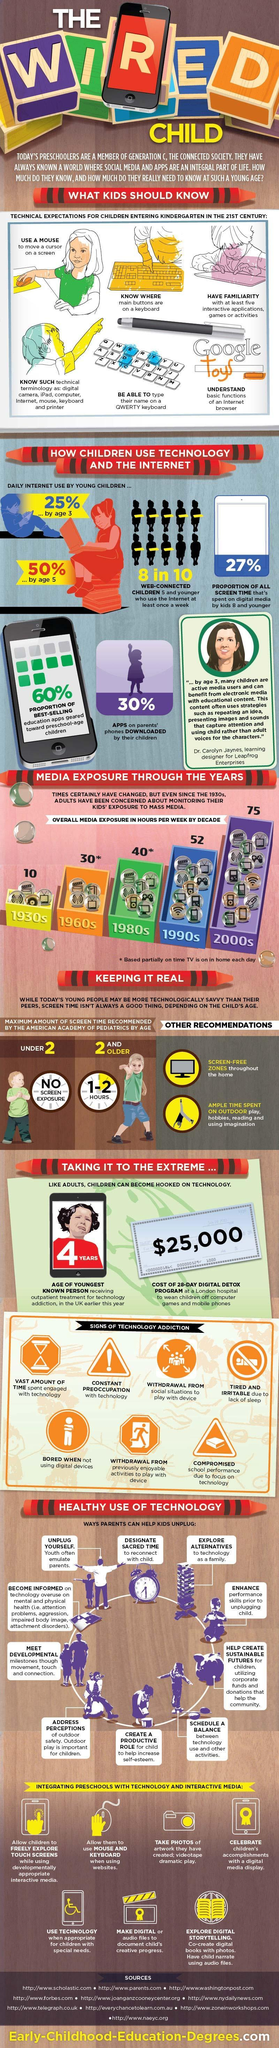What is the cost of a 28 day digital detox program in London?
Answer the question with a short phrase. $25,000 What should be enhanced prior to unplugging a child from technology? Performance skills What is the second 'sign of technology addiction' mentioned here? Constant preoccupation with technology What is the age of the youngest person receiving treatment for technology addiction? 4 years How many hours per week were children exposed to media in the 1930s? 10 Besides restricting screen time, what are the two 'other recommendations' to reduce screen time? Screen-free zones, ample time spent on outdoor What is the maximum amount of screen time recommended by pediatricians for children under 2? New screen exposure According to pediatricians, how many hours of screen time should a child of age 2 be allowed to have? 1 - 2 hours How many signs of technology addictions are shown here? 7 Who do youth often emulate? Parents What percent of the educational apps are aimed towards preschool students? 60% How many more hours/week exposure do the 1990's children have when compared to to the 1980s? 12 Which decade shows the second highest media exposure in children? 1990s What percentage of apps on a parent's phone is downloaded by children? 30% What is the daily internet usage of a 3 year old child? 25% What are the three ways through which parents should help children 'meet developmental milestones'? Movement, touch and connection Out of all the apps downloaded on a parent's phone, what percent is 'not' downloaded by their children? 70% On what is the child's creative progress documented, in a technology integrated preschool? Digital or audio files When should children be allowed to use a mouse and keyboard? When using websites 